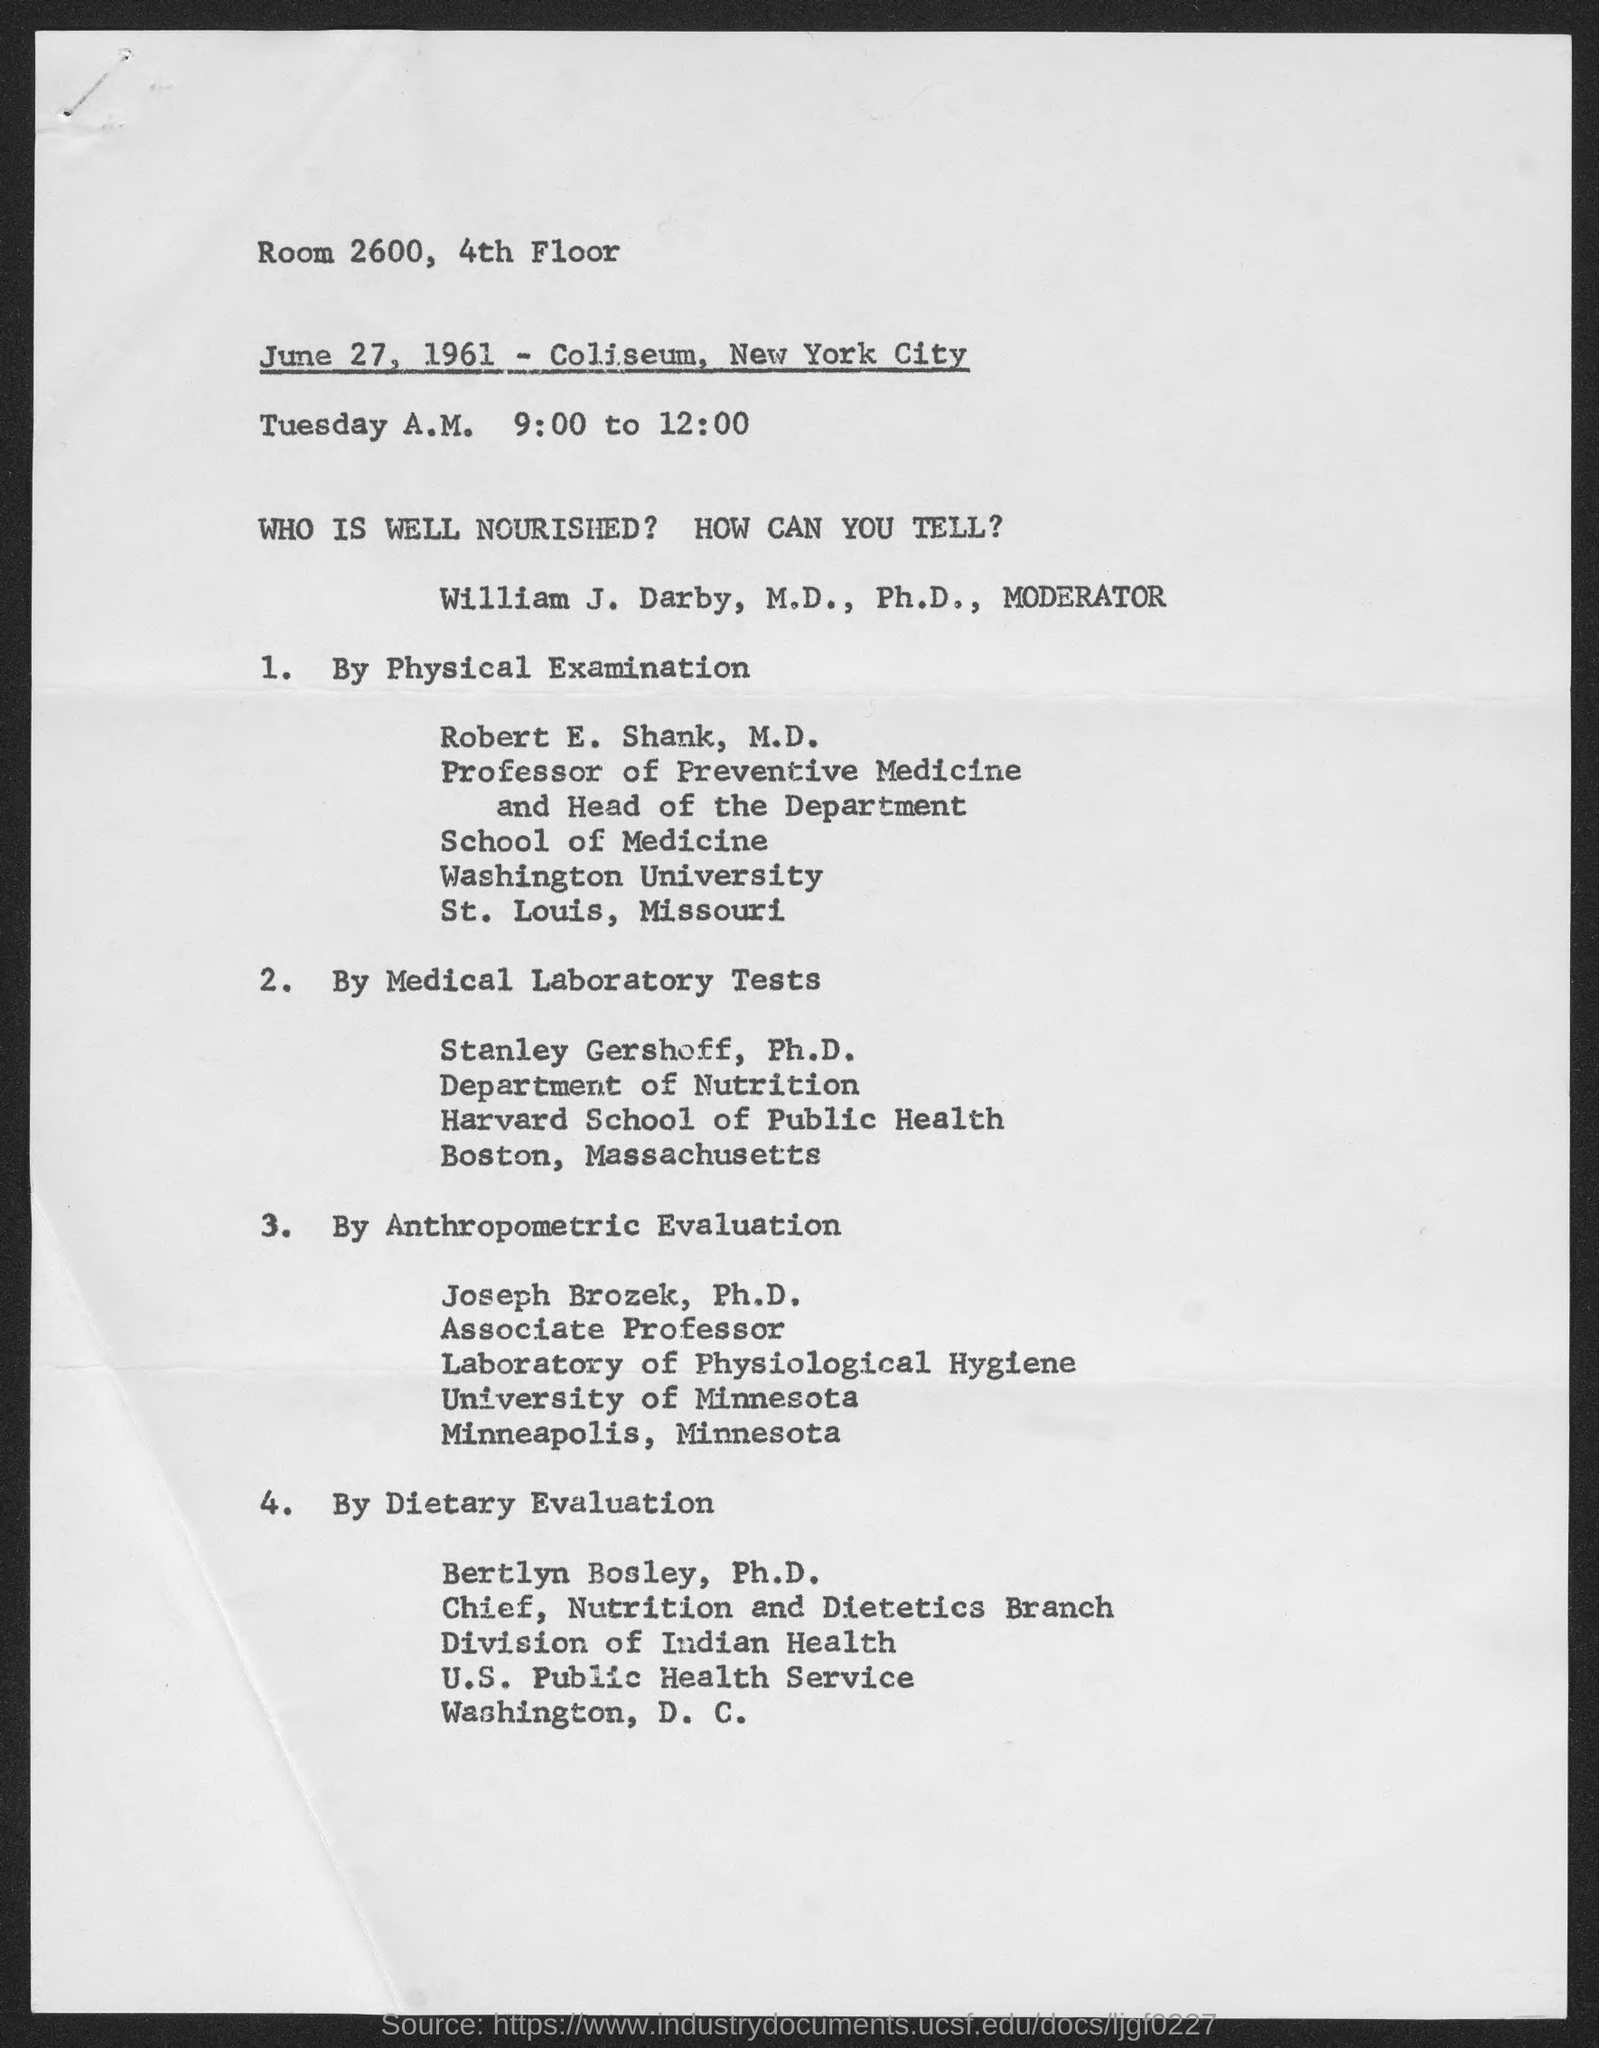What is the date on the document?
Offer a very short reply. June 27, 1961. Where is it held?
Offer a terse response. Room 2600, 4th Floor. 